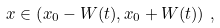Convert formula to latex. <formula><loc_0><loc_0><loc_500><loc_500>x \in \left ( x _ { 0 } - W ( t ) , x _ { 0 } + W ( t ) \right ) \, ,</formula> 